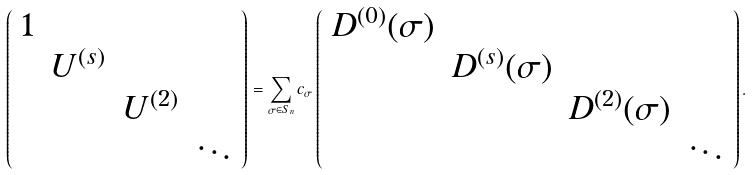<formula> <loc_0><loc_0><loc_500><loc_500>\left ( \begin{array} { c c c c } 1 & & & \\ & U ^ { ( s ) } & & \\ & & U ^ { ( 2 ) } & \\ & & & \ddots \end{array} \right ) = \sum _ { \sigma \in S _ { n } } c _ { \sigma } \left ( \begin{array} { c c c c } D ^ { ( 0 ) } ( \sigma ) & & & \\ & D ^ { ( s ) } ( \sigma ) & & \\ & & D ^ { ( 2 ) } ( \sigma ) & \\ & & & \ddots \end{array} \right ) .</formula> 